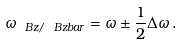Convert formula to latex. <formula><loc_0><loc_0><loc_500><loc_500>\omega _ { \ B z / \ B z b a r } = \omega \pm \frac { 1 } { 2 } \Delta \omega \, .</formula> 